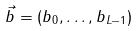<formula> <loc_0><loc_0><loc_500><loc_500>\vec { b } = ( b _ { 0 } , \dots , b _ { L - 1 } )</formula> 